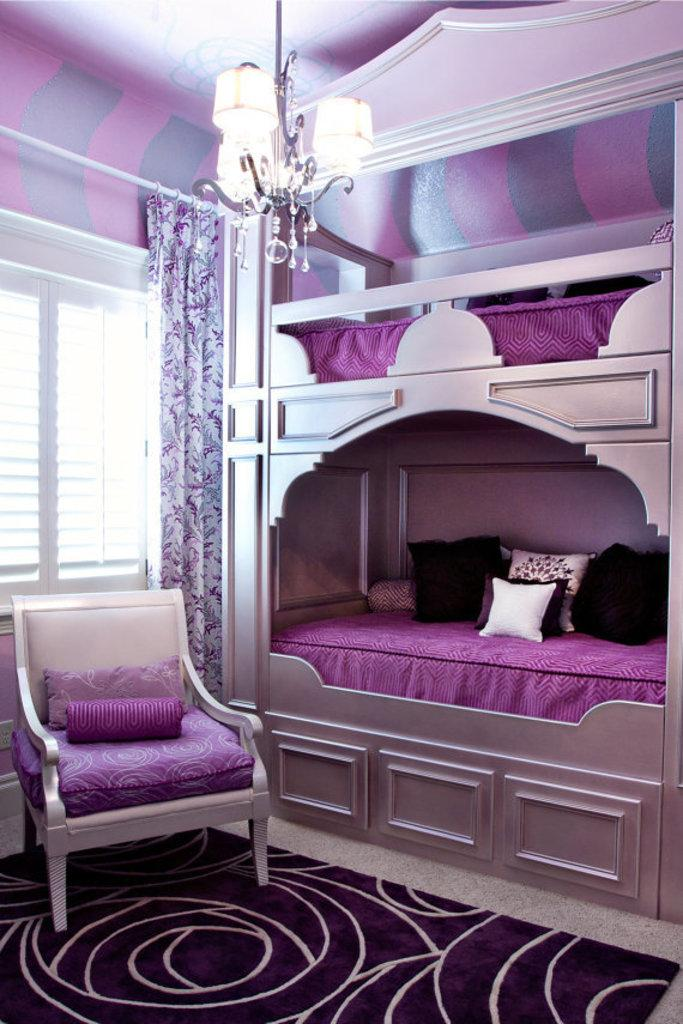What color is the bed in the image? The bed in the image is pink. What furniture is located near the window? There is a chair behind one window in the image. What type of window treatment is present in the image? A curtain is present near the window. What lighting fixture is attached to the roof of the room? A chandelier is attached to the roof of the room. What type of floor covering is visible at the bottom of the image? There is a carpet at the bottom of the image. Can you see any waves in the image? There are no waves present in the image; it features a room with a pink bed, a chair, a curtain, a chandelier, and a carpet. What type of quill is used to write on the bed? There is no quill present in the image, and the bed is not being used for writing. 